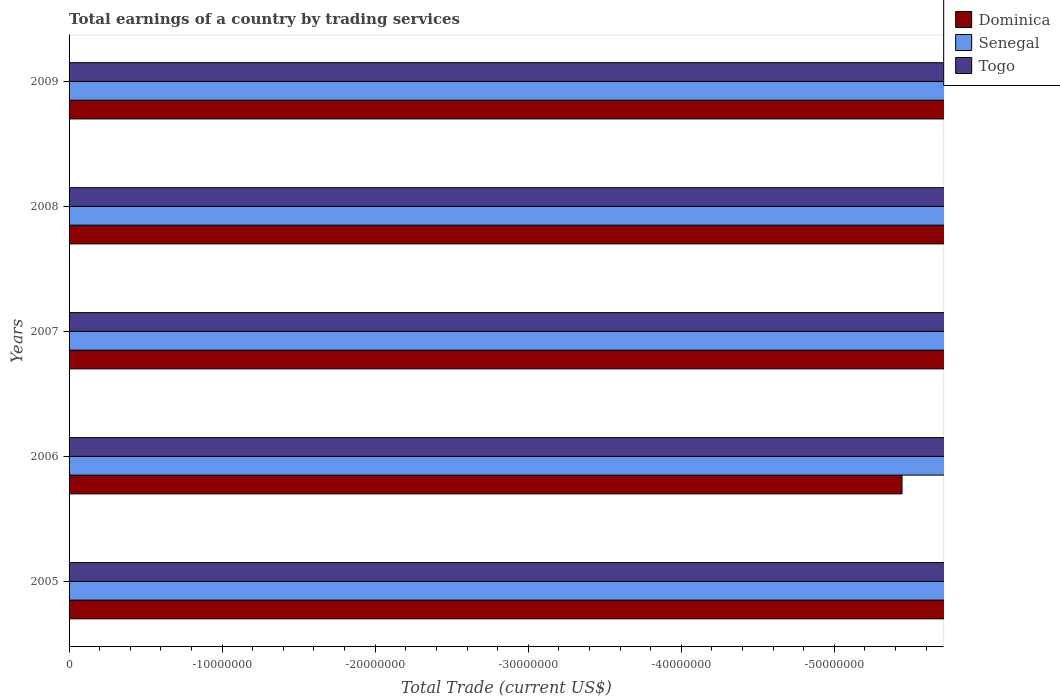Are the number of bars on each tick of the Y-axis equal?
Give a very brief answer. Yes. How many bars are there on the 1st tick from the top?
Offer a terse response. 0. How many bars are there on the 3rd tick from the bottom?
Offer a terse response. 0. What is the label of the 2nd group of bars from the top?
Offer a very short reply. 2008. In how many cases, is the number of bars for a given year not equal to the number of legend labels?
Give a very brief answer. 5. What is the total earnings in Senegal in 2007?
Make the answer very short. 0. In how many years, is the total earnings in Dominica greater than the average total earnings in Dominica taken over all years?
Provide a succinct answer. 0. Is it the case that in every year, the sum of the total earnings in Dominica and total earnings in Togo is greater than the total earnings in Senegal?
Offer a very short reply. No. How many bars are there?
Give a very brief answer. 0. Does the graph contain grids?
Offer a very short reply. No. Where does the legend appear in the graph?
Your answer should be compact. Top right. How are the legend labels stacked?
Your answer should be compact. Vertical. What is the title of the graph?
Provide a short and direct response. Total earnings of a country by trading services. What is the label or title of the X-axis?
Ensure brevity in your answer.  Total Trade (current US$). What is the Total Trade (current US$) of Dominica in 2005?
Your answer should be very brief. 0. What is the Total Trade (current US$) of Senegal in 2005?
Give a very brief answer. 0. What is the Total Trade (current US$) of Togo in 2006?
Ensure brevity in your answer.  0. What is the Total Trade (current US$) in Dominica in 2007?
Keep it short and to the point. 0. What is the Total Trade (current US$) of Togo in 2007?
Your response must be concise. 0. What is the Total Trade (current US$) in Dominica in 2008?
Your answer should be compact. 0. What is the Total Trade (current US$) of Senegal in 2008?
Offer a terse response. 0. What is the Total Trade (current US$) of Togo in 2009?
Ensure brevity in your answer.  0. What is the total Total Trade (current US$) in Dominica in the graph?
Offer a very short reply. 0. What is the total Total Trade (current US$) of Senegal in the graph?
Make the answer very short. 0. What is the average Total Trade (current US$) of Senegal per year?
Offer a terse response. 0. What is the average Total Trade (current US$) of Togo per year?
Make the answer very short. 0. 